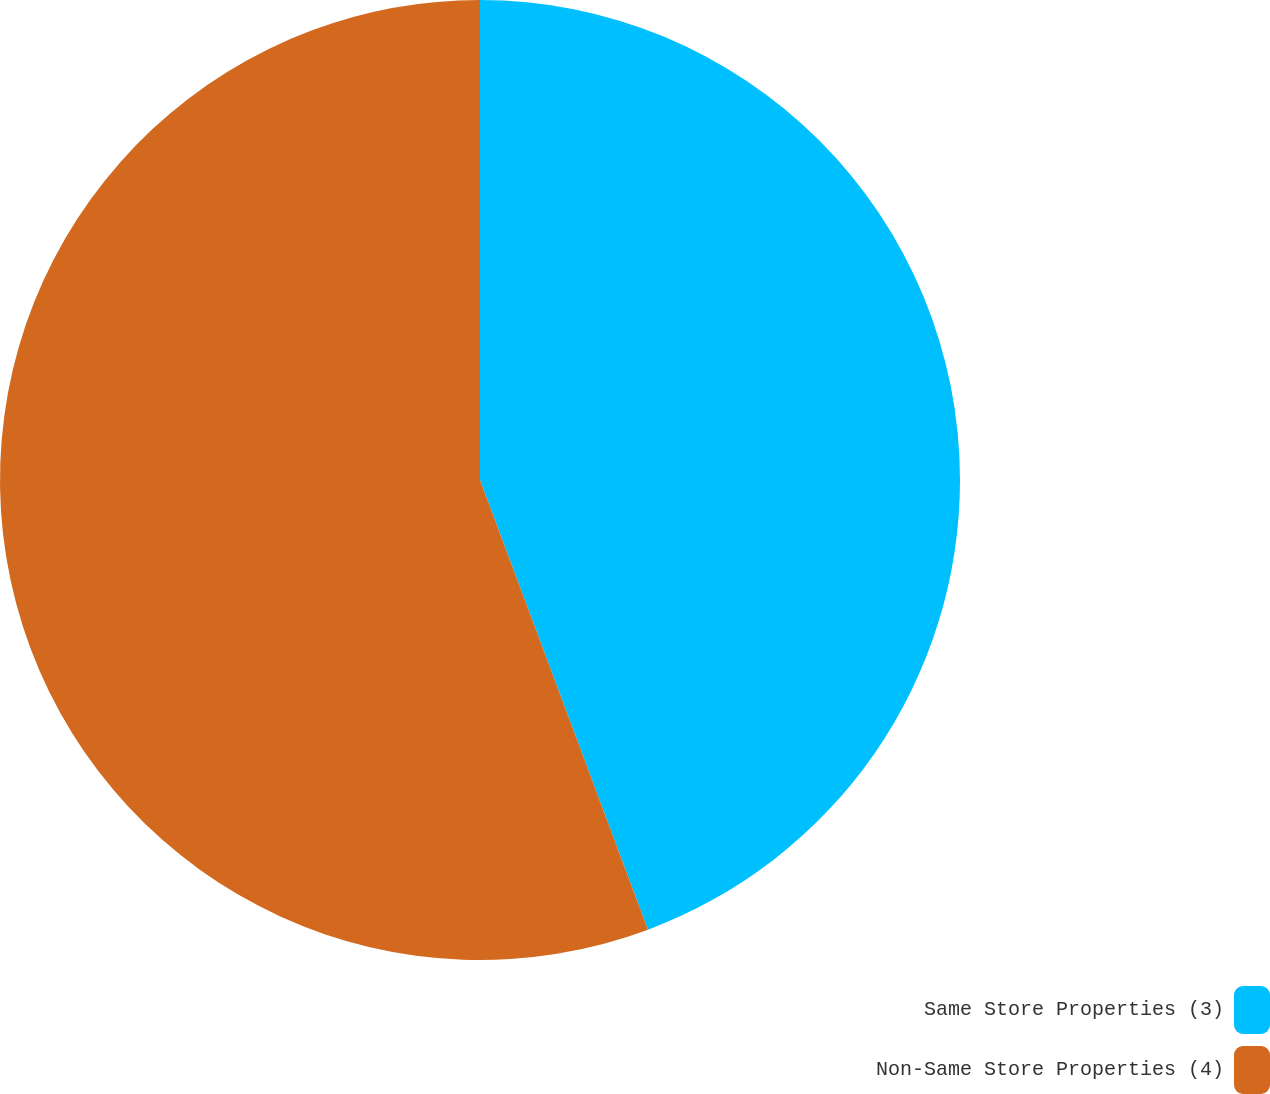<chart> <loc_0><loc_0><loc_500><loc_500><pie_chart><fcel>Same Store Properties (3)<fcel>Non-Same Store Properties (4)<nl><fcel>44.31%<fcel>55.69%<nl></chart> 